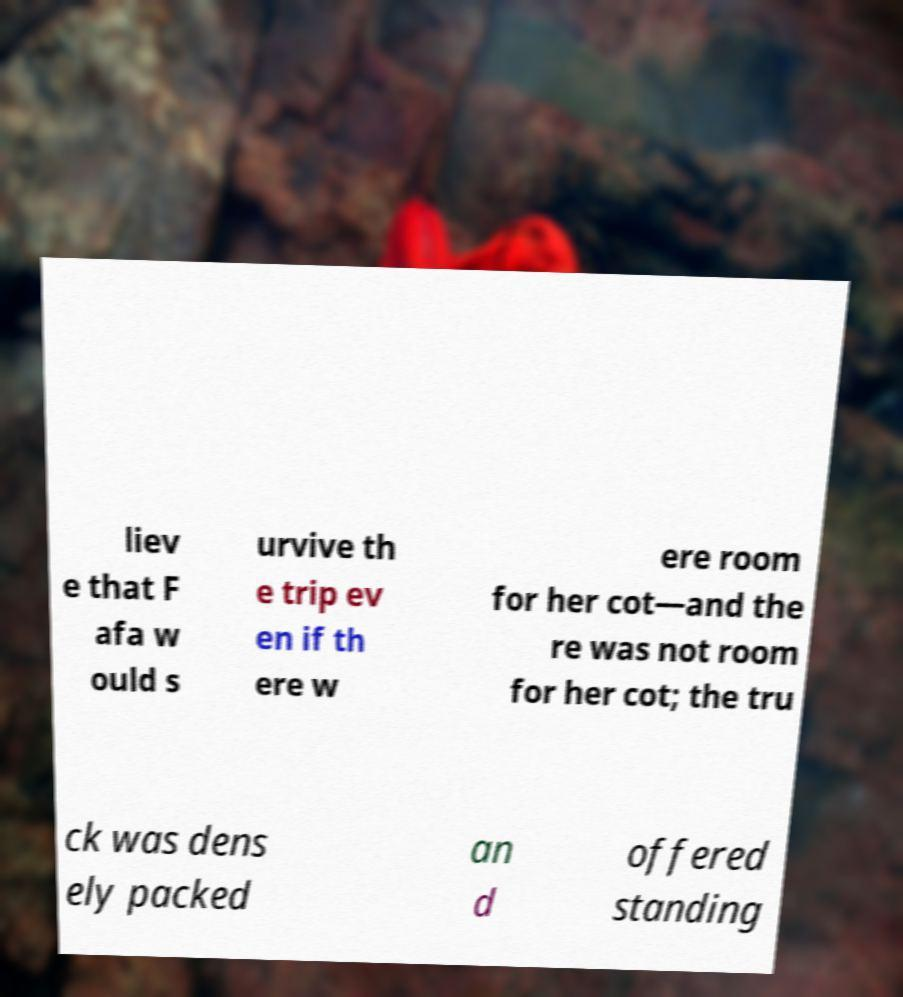Can you accurately transcribe the text from the provided image for me? liev e that F afa w ould s urvive th e trip ev en if th ere w ere room for her cot—and the re was not room for her cot; the tru ck was dens ely packed an d offered standing 